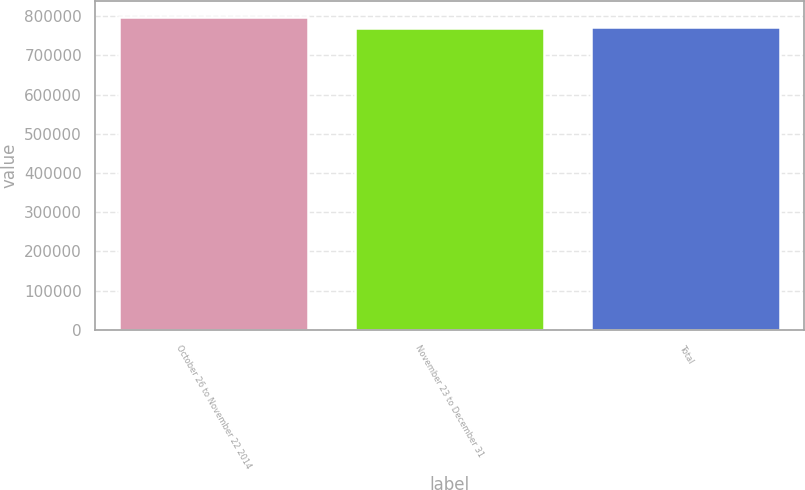<chart> <loc_0><loc_0><loc_500><loc_500><bar_chart><fcel>October 26 to November 22 2014<fcel>November 23 to December 31<fcel>Total<nl><fcel>797661<fcel>768758<fcel>771648<nl></chart> 